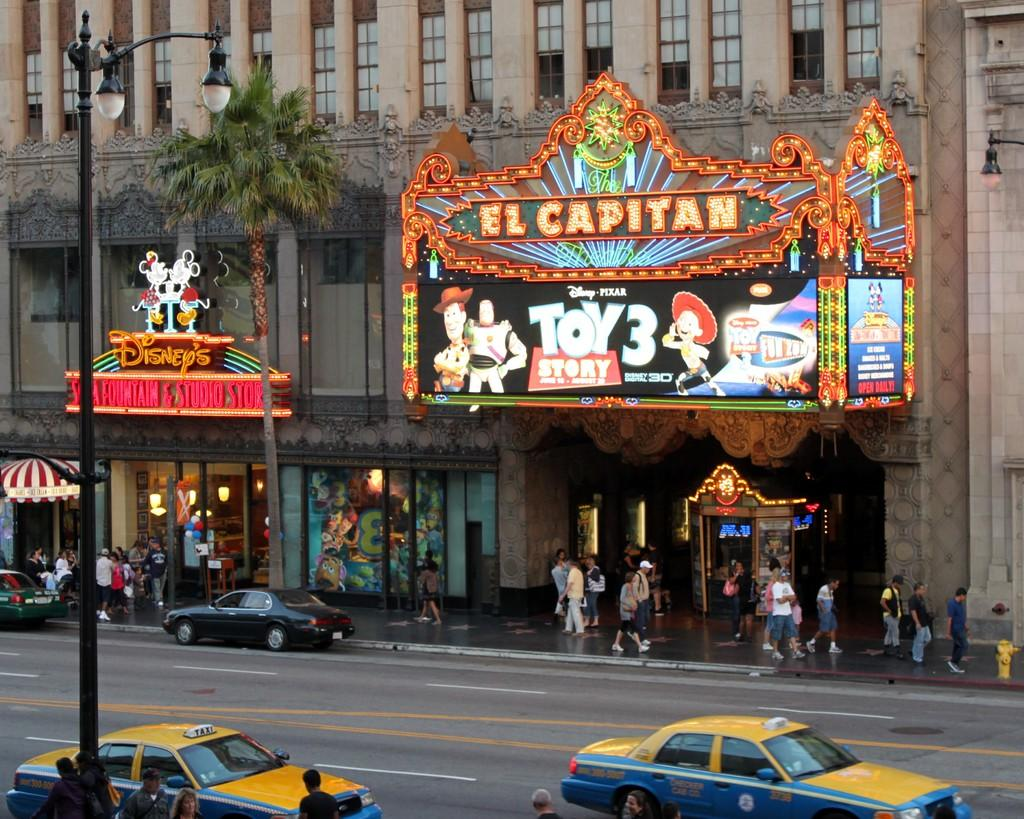<image>
Give a short and clear explanation of the subsequent image. A colorful theater marquis has El Capitan at the top. 